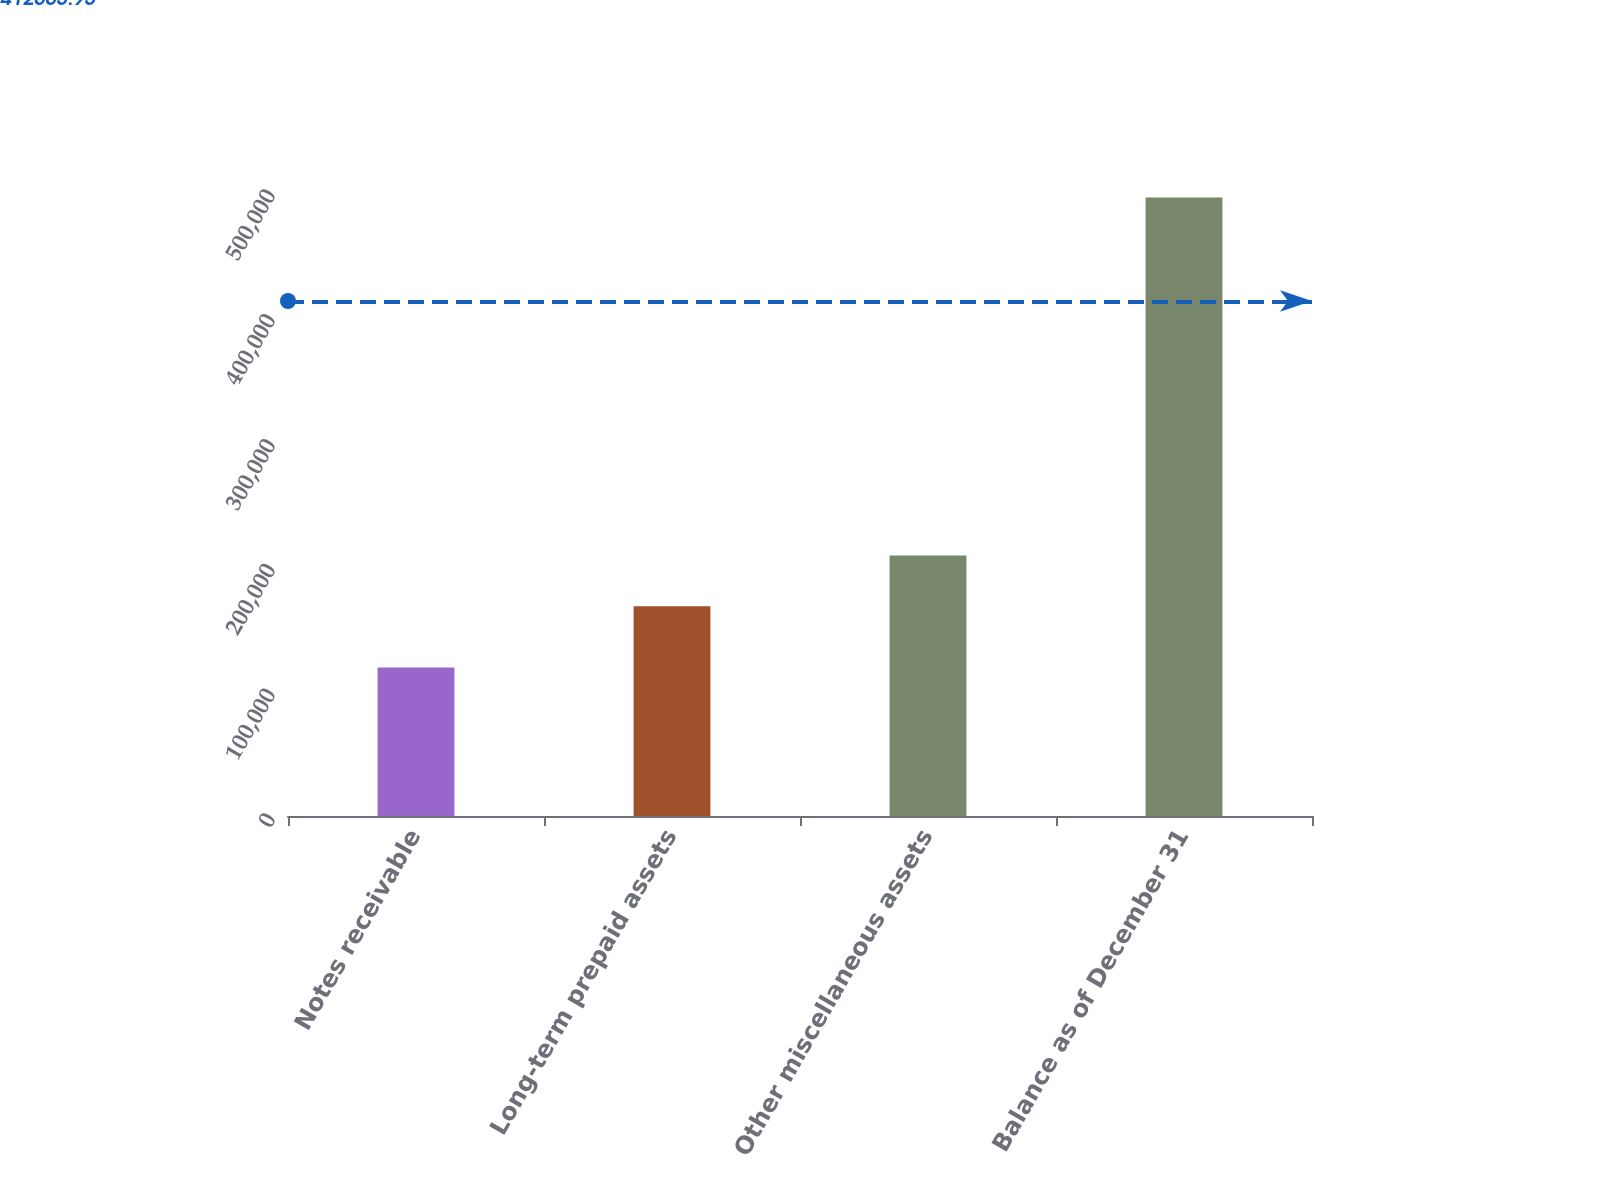Convert chart. <chart><loc_0><loc_0><loc_500><loc_500><bar_chart><fcel>Notes receivable<fcel>Long-term prepaid assets<fcel>Other miscellaneous assets<fcel>Balance as of December 31<nl><fcel>118892<fcel>167975<fcel>208748<fcel>495615<nl></chart> 